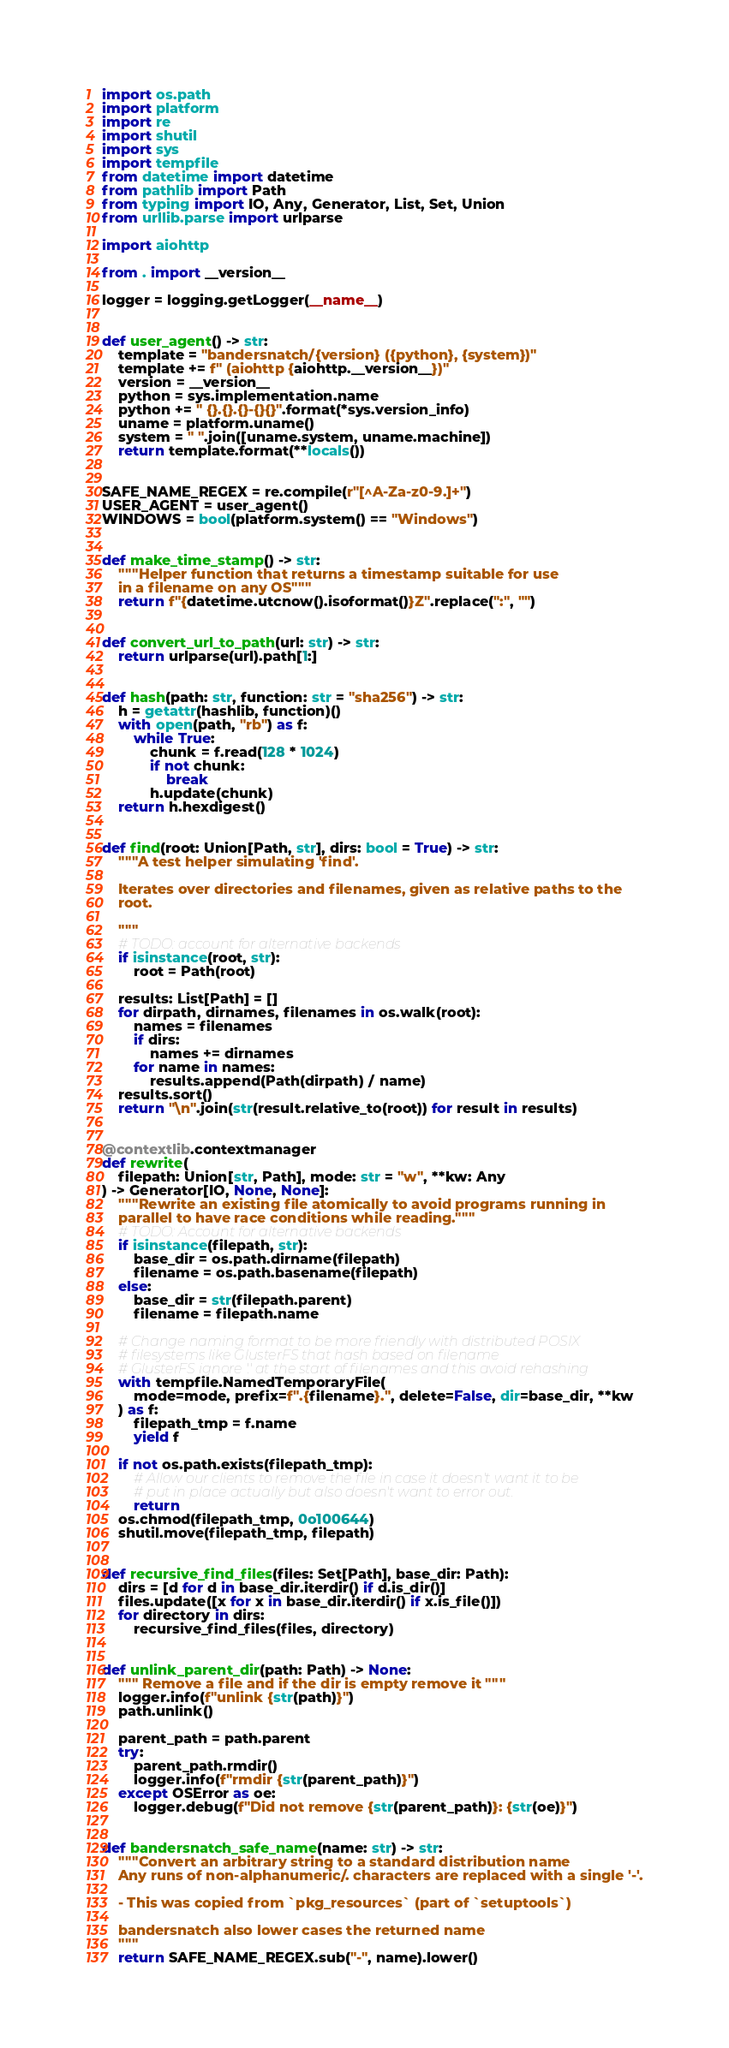<code> <loc_0><loc_0><loc_500><loc_500><_Python_>import os.path
import platform
import re
import shutil
import sys
import tempfile
from datetime import datetime
from pathlib import Path
from typing import IO, Any, Generator, List, Set, Union
from urllib.parse import urlparse

import aiohttp

from . import __version__

logger = logging.getLogger(__name__)


def user_agent() -> str:
    template = "bandersnatch/{version} ({python}, {system})"
    template += f" (aiohttp {aiohttp.__version__})"
    version = __version__
    python = sys.implementation.name
    python += " {}.{}.{}-{}{}".format(*sys.version_info)
    uname = platform.uname()
    system = " ".join([uname.system, uname.machine])
    return template.format(**locals())


SAFE_NAME_REGEX = re.compile(r"[^A-Za-z0-9.]+")
USER_AGENT = user_agent()
WINDOWS = bool(platform.system() == "Windows")


def make_time_stamp() -> str:
    """Helper function that returns a timestamp suitable for use
    in a filename on any OS"""
    return f"{datetime.utcnow().isoformat()}Z".replace(":", "")


def convert_url_to_path(url: str) -> str:
    return urlparse(url).path[1:]


def hash(path: str, function: str = "sha256") -> str:
    h = getattr(hashlib, function)()
    with open(path, "rb") as f:
        while True:
            chunk = f.read(128 * 1024)
            if not chunk:
                break
            h.update(chunk)
    return h.hexdigest()


def find(root: Union[Path, str], dirs: bool = True) -> str:
    """A test helper simulating 'find'.

    Iterates over directories and filenames, given as relative paths to the
    root.

    """
    # TODO: account for alternative backends
    if isinstance(root, str):
        root = Path(root)

    results: List[Path] = []
    for dirpath, dirnames, filenames in os.walk(root):
        names = filenames
        if dirs:
            names += dirnames
        for name in names:
            results.append(Path(dirpath) / name)
    results.sort()
    return "\n".join(str(result.relative_to(root)) for result in results)


@contextlib.contextmanager
def rewrite(
    filepath: Union[str, Path], mode: str = "w", **kw: Any
) -> Generator[IO, None, None]:
    """Rewrite an existing file atomically to avoid programs running in
    parallel to have race conditions while reading."""
    # TODO: Account for alternative backends
    if isinstance(filepath, str):
        base_dir = os.path.dirname(filepath)
        filename = os.path.basename(filepath)
    else:
        base_dir = str(filepath.parent)
        filename = filepath.name

    # Change naming format to be more friendly with distributed POSIX
    # filesystems like GlusterFS that hash based on filename
    # GlusterFS ignore '.' at the start of filenames and this avoid rehashing
    with tempfile.NamedTemporaryFile(
        mode=mode, prefix=f".{filename}.", delete=False, dir=base_dir, **kw
    ) as f:
        filepath_tmp = f.name
        yield f

    if not os.path.exists(filepath_tmp):
        # Allow our clients to remove the file in case it doesn't want it to be
        # put in place actually but also doesn't want to error out.
        return
    os.chmod(filepath_tmp, 0o100644)
    shutil.move(filepath_tmp, filepath)


def recursive_find_files(files: Set[Path], base_dir: Path):
    dirs = [d for d in base_dir.iterdir() if d.is_dir()]
    files.update([x for x in base_dir.iterdir() if x.is_file()])
    for directory in dirs:
        recursive_find_files(files, directory)


def unlink_parent_dir(path: Path) -> None:
    """ Remove a file and if the dir is empty remove it """
    logger.info(f"unlink {str(path)}")
    path.unlink()

    parent_path = path.parent
    try:
        parent_path.rmdir()
        logger.info(f"rmdir {str(parent_path)}")
    except OSError as oe:
        logger.debug(f"Did not remove {str(parent_path)}: {str(oe)}")


def bandersnatch_safe_name(name: str) -> str:
    """Convert an arbitrary string to a standard distribution name
    Any runs of non-alphanumeric/. characters are replaced with a single '-'.

    - This was copied from `pkg_resources` (part of `setuptools`)

    bandersnatch also lower cases the returned name
    """
    return SAFE_NAME_REGEX.sub("-", name).lower()
</code> 